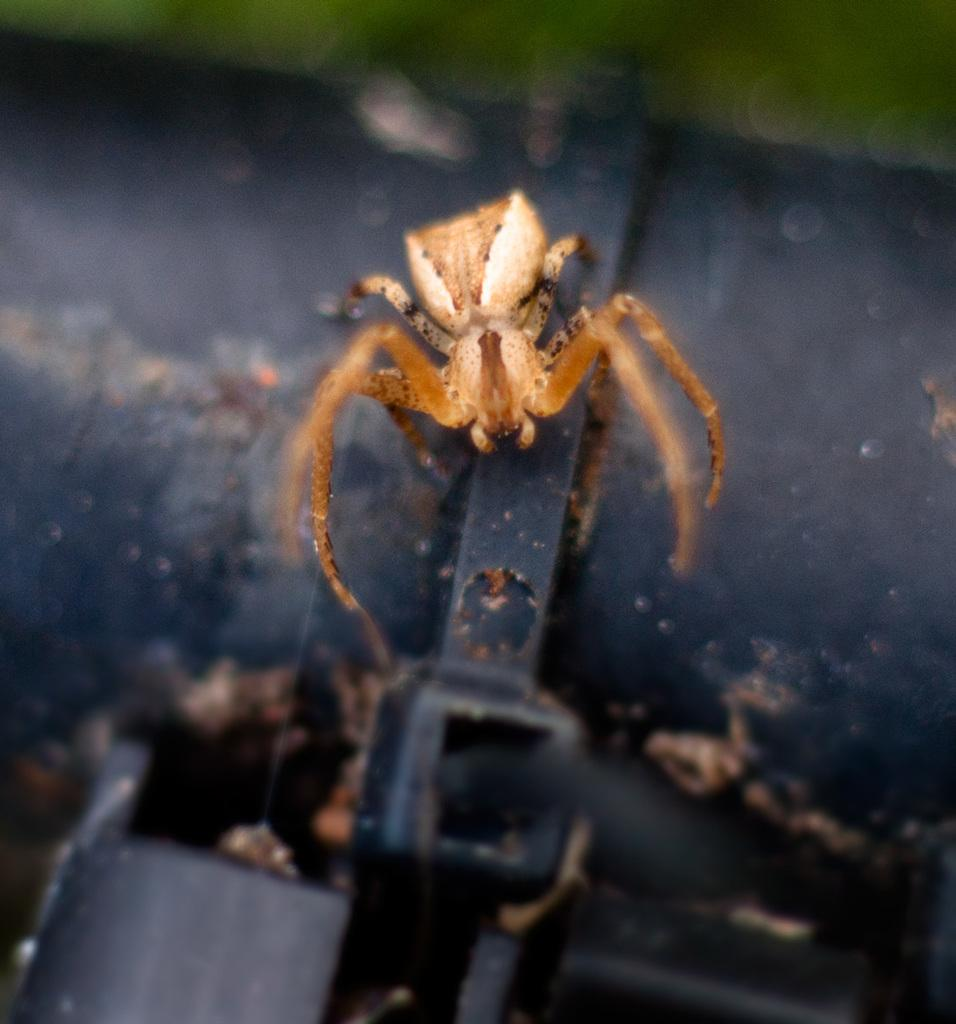What type of photography is used in the image? The image is a macro photography. What is the main subject of the macro photography? The subject of the macro photography is a spider. How is the background of the image depicted? The background of the image is blurred. What type of boats can be seen in the image? There are no boats present in the image; it features a macro photograph of a spider. What form does the spider take in the image? The spider's form cannot be determined from the image alone, as macro photography often focuses on a small portion of the subject. 